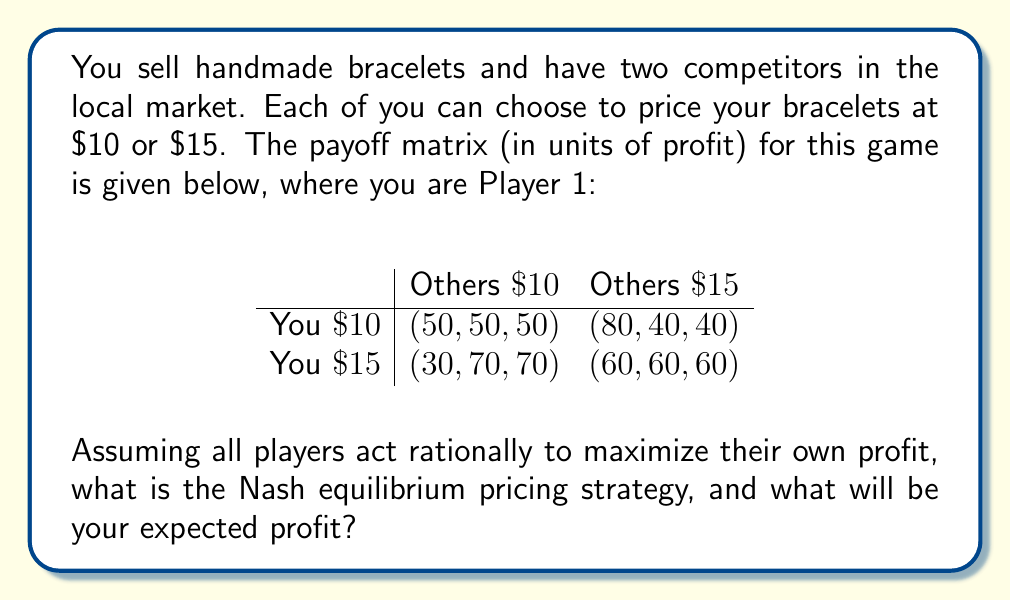Could you help me with this problem? To solve this game theory problem, we need to follow these steps:

1) First, let's understand the payoff matrix. The first number in each cell represents your profit, while the other two numbers represent the profits of your competitors.

2) To find the Nash equilibrium, we need to determine the best response for each player given the other players' strategies.

3) If you price at $10:
   - If others price at $10, you get 50
   - If others price at $15, you get 80
   So, if others price at $10, you prefer $10. If others price at $15, you prefer $10.

4) If you price at $15:
   - If others price at $10, you get 30
   - If others price at $15, you get 60
   So, regardless of what others do, you prefer $10.

5) For the other players:
   - If you price at $10, they prefer $10 (50 > 40)
   - If you price at $15, they prefer $10 (70 > 60)

6) Therefore, the Nash equilibrium is when all players price at $10, as no player has an incentive to unilaterally change their strategy.

7) In this Nash equilibrium, your expected profit is $50.
Answer: Nash equilibrium: All price at $10. Your expected profit: $50. 